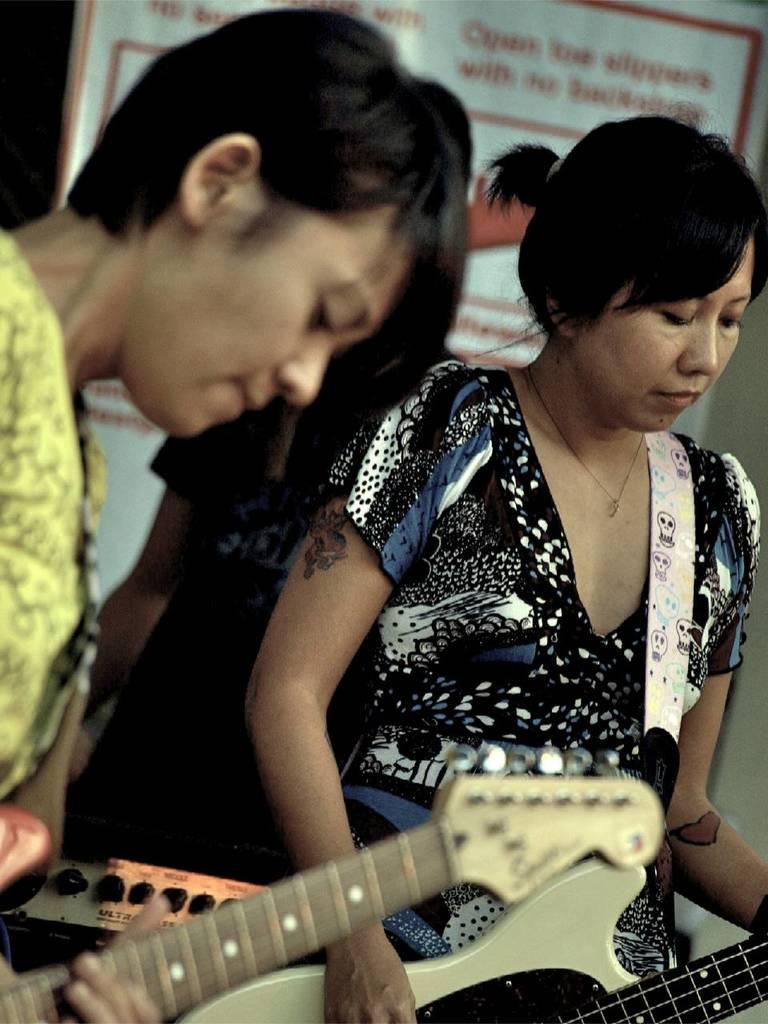How many people are in the image? There are two women in the image. What are the women doing in the image? The women are playing guitar. What type of tin can be seen in the image? There is no tin present in the image; it features two women playing guitar. 